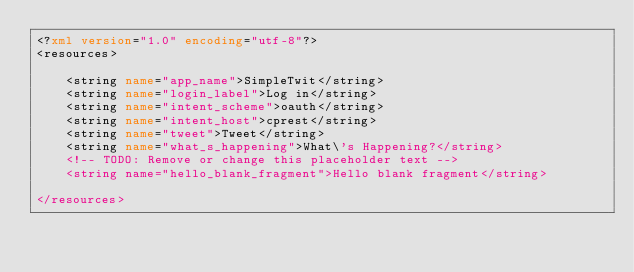Convert code to text. <code><loc_0><loc_0><loc_500><loc_500><_XML_><?xml version="1.0" encoding="utf-8"?>
<resources>

    <string name="app_name">SimpleTwit</string>
    <string name="login_label">Log in</string>
    <string name="intent_scheme">oauth</string>
    <string name="intent_host">cprest</string>
    <string name="tweet">Tweet</string>
    <string name="what_s_happening">What\'s Happening?</string>
    <!-- TODO: Remove or change this placeholder text -->
    <string name="hello_blank_fragment">Hello blank fragment</string>

</resources></code> 